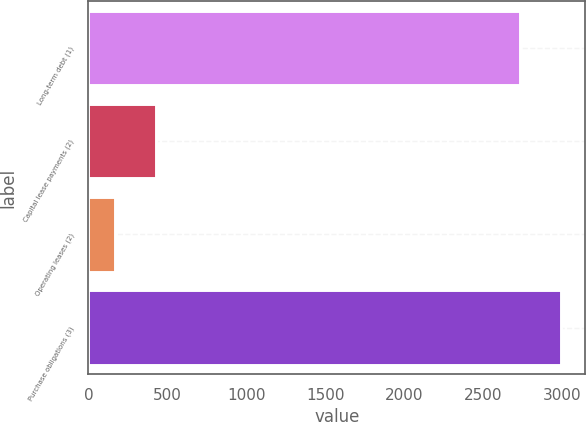<chart> <loc_0><loc_0><loc_500><loc_500><bar_chart><fcel>Long-term debt (1)<fcel>Capital lease payments (2)<fcel>Operating leases (2)<fcel>Purchase obligations (3)<nl><fcel>2731<fcel>428.5<fcel>166<fcel>2993.5<nl></chart> 